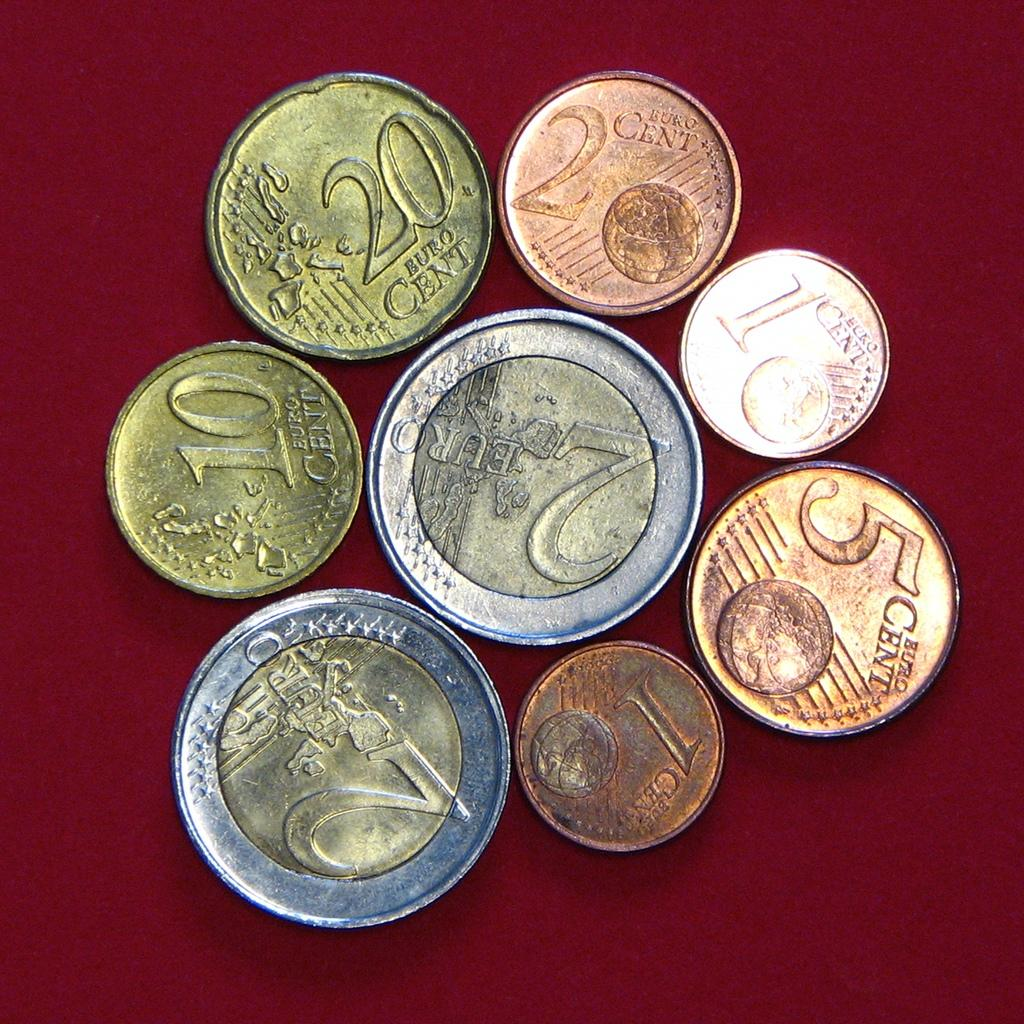<image>
Present a compact description of the photo's key features. The Euro coins on the red background range in value from 1 Euro cent to 2 Euros. 